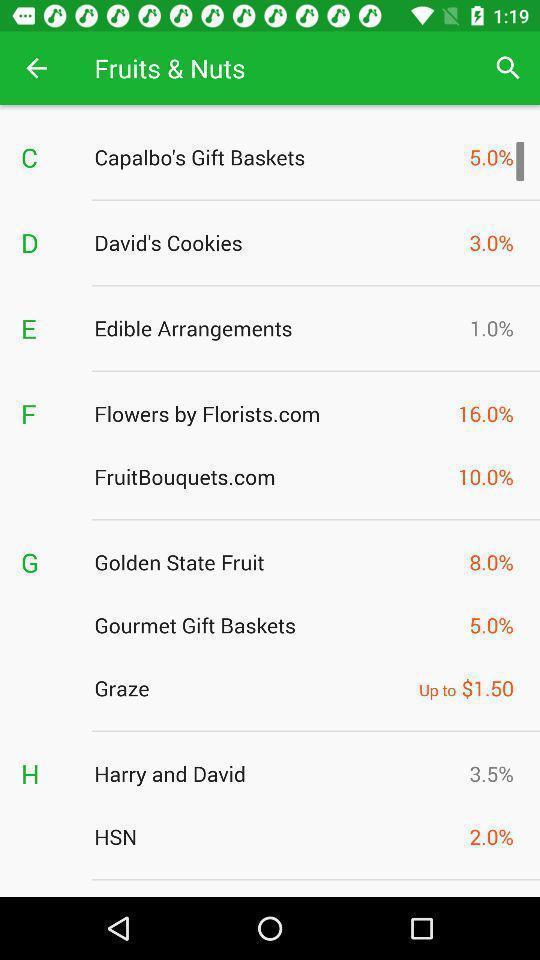Please provide a description for this image. Page showing different deals available. 